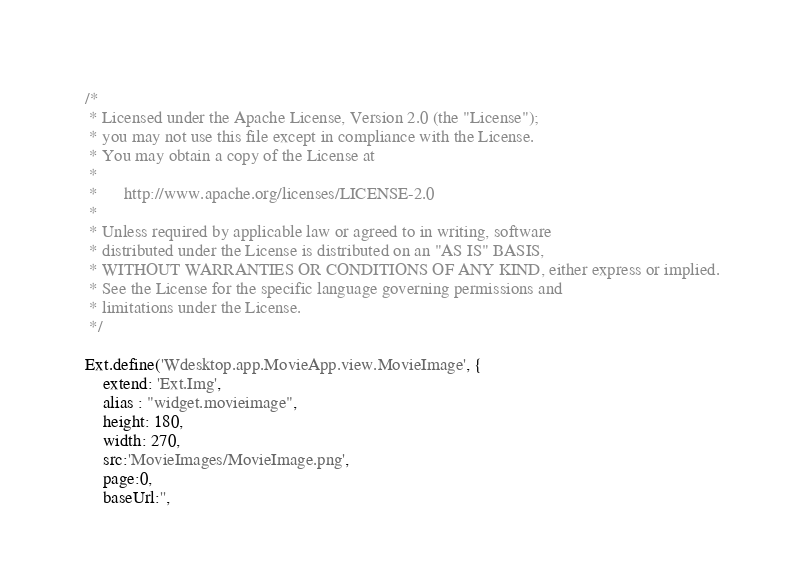Convert code to text. <code><loc_0><loc_0><loc_500><loc_500><_JavaScript_>/*
 * Licensed under the Apache License, Version 2.0 (the "License");
 * you may not use this file except in compliance with the License.
 * You may obtain a copy of the License at
 *
 *      http://www.apache.org/licenses/LICENSE-2.0
 *
 * Unless required by applicable law or agreed to in writing, software
 * distributed under the License is distributed on an "AS IS" BASIS,
 * WITHOUT WARRANTIES OR CONDITIONS OF ANY KIND, either express or implied.
 * See the License for the specific language governing permissions and
 * limitations under the License.
 */
 
Ext.define('Wdesktop.app.MovieApp.view.MovieImage', {
    extend: 'Ext.Img',
    alias : "widget.movieimage",
    height: 180,
    width: 270,
    src:'MovieImages/MovieImage.png',
    page:0,
    baseUrl:'',
</code> 